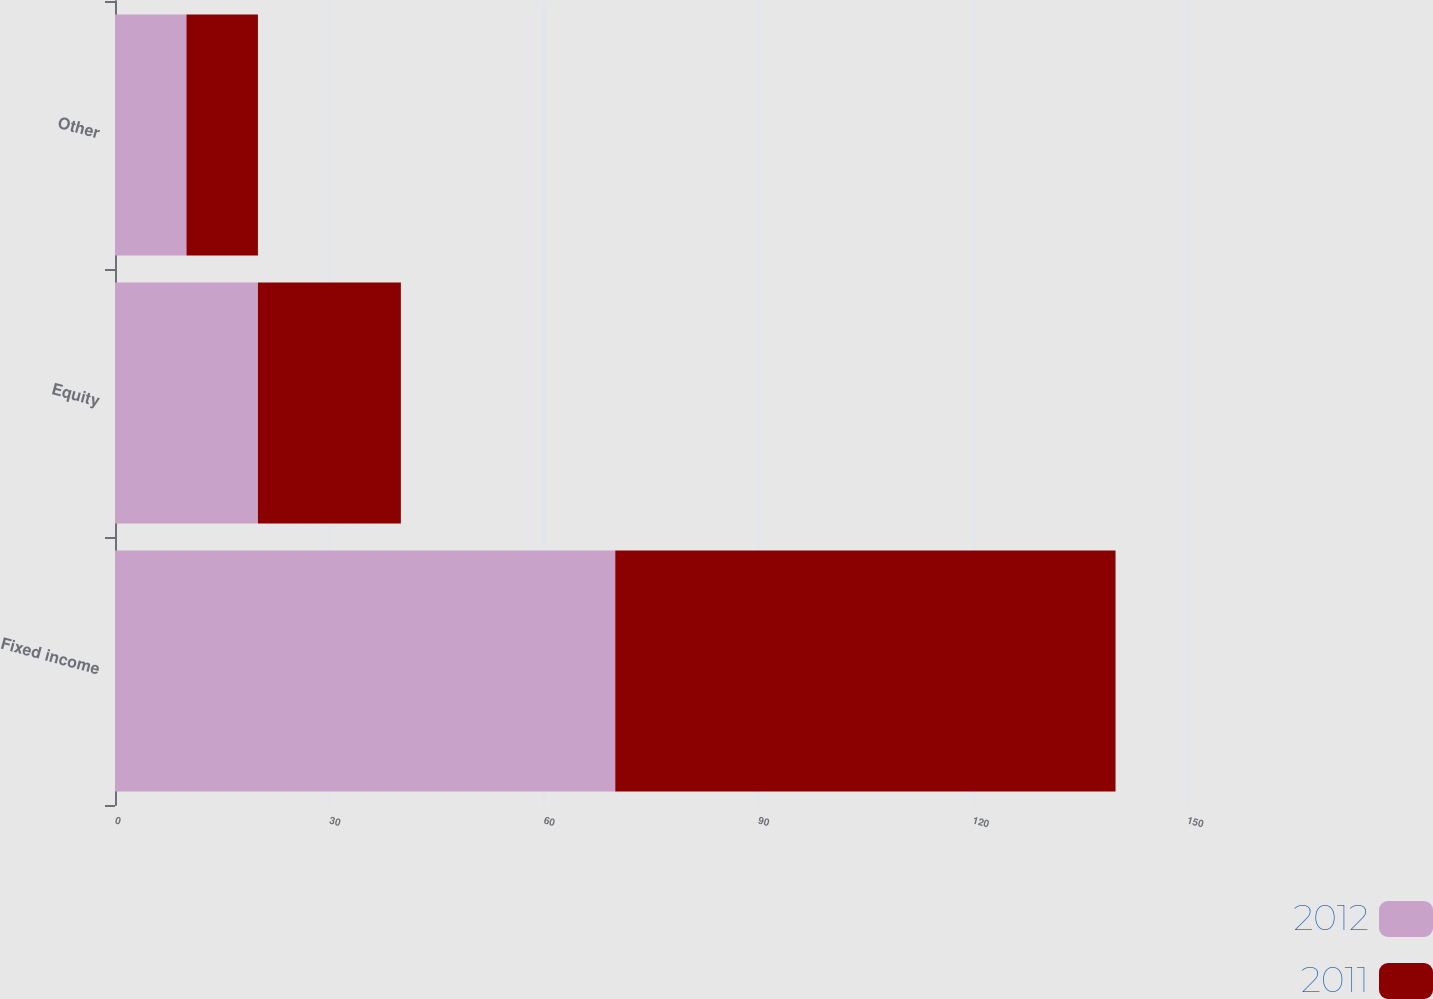<chart> <loc_0><loc_0><loc_500><loc_500><stacked_bar_chart><ecel><fcel>Fixed income<fcel>Equity<fcel>Other<nl><fcel>2012<fcel>70<fcel>20<fcel>10<nl><fcel>2011<fcel>70<fcel>20<fcel>10<nl></chart> 